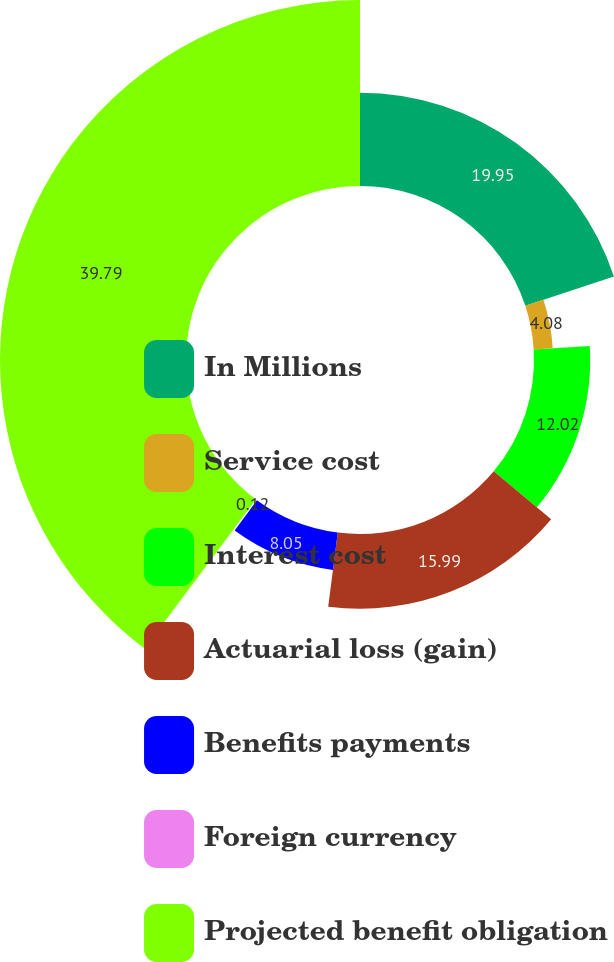Convert chart. <chart><loc_0><loc_0><loc_500><loc_500><pie_chart><fcel>In Millions<fcel>Service cost<fcel>Interest cost<fcel>Actuarial loss (gain)<fcel>Benefits payments<fcel>Foreign currency<fcel>Projected benefit obligation<nl><fcel>19.95%<fcel>4.08%<fcel>12.02%<fcel>15.99%<fcel>8.05%<fcel>0.12%<fcel>39.79%<nl></chart> 